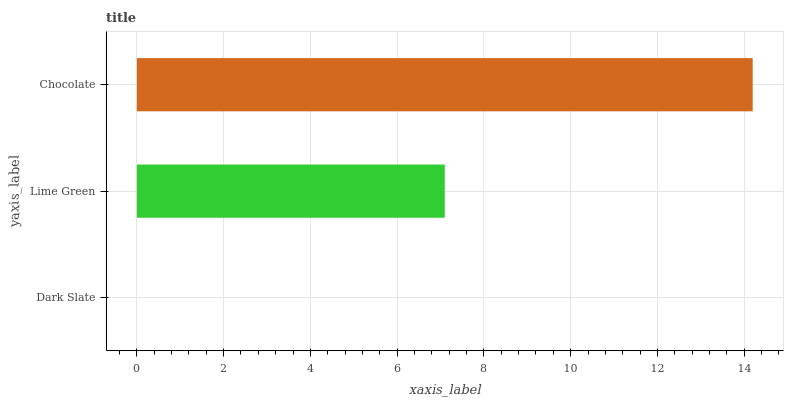Is Dark Slate the minimum?
Answer yes or no. Yes. Is Chocolate the maximum?
Answer yes or no. Yes. Is Lime Green the minimum?
Answer yes or no. No. Is Lime Green the maximum?
Answer yes or no. No. Is Lime Green greater than Dark Slate?
Answer yes or no. Yes. Is Dark Slate less than Lime Green?
Answer yes or no. Yes. Is Dark Slate greater than Lime Green?
Answer yes or no. No. Is Lime Green less than Dark Slate?
Answer yes or no. No. Is Lime Green the high median?
Answer yes or no. Yes. Is Lime Green the low median?
Answer yes or no. Yes. Is Dark Slate the high median?
Answer yes or no. No. Is Dark Slate the low median?
Answer yes or no. No. 